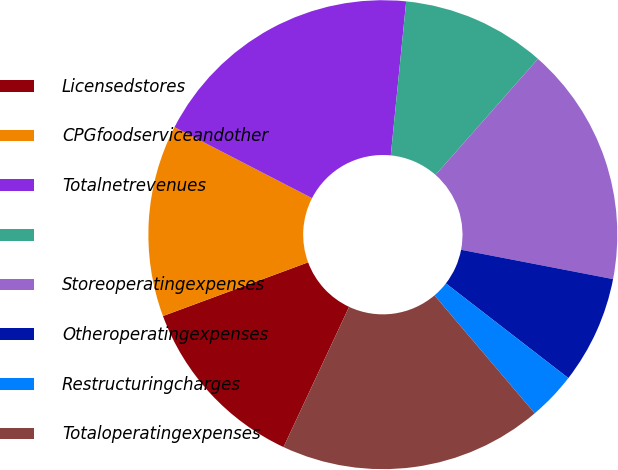Convert chart. <chart><loc_0><loc_0><loc_500><loc_500><pie_chart><fcel>Licensedstores<fcel>CPGfoodserviceandother<fcel>Totalnetrevenues<fcel>Unnamed: 3<fcel>Storeoperatingexpenses<fcel>Otheroperatingexpenses<fcel>Restructuringcharges<fcel>Totaloperatingexpenses<nl><fcel>12.4%<fcel>13.22%<fcel>19.01%<fcel>9.92%<fcel>16.53%<fcel>7.44%<fcel>3.31%<fcel>18.18%<nl></chart> 